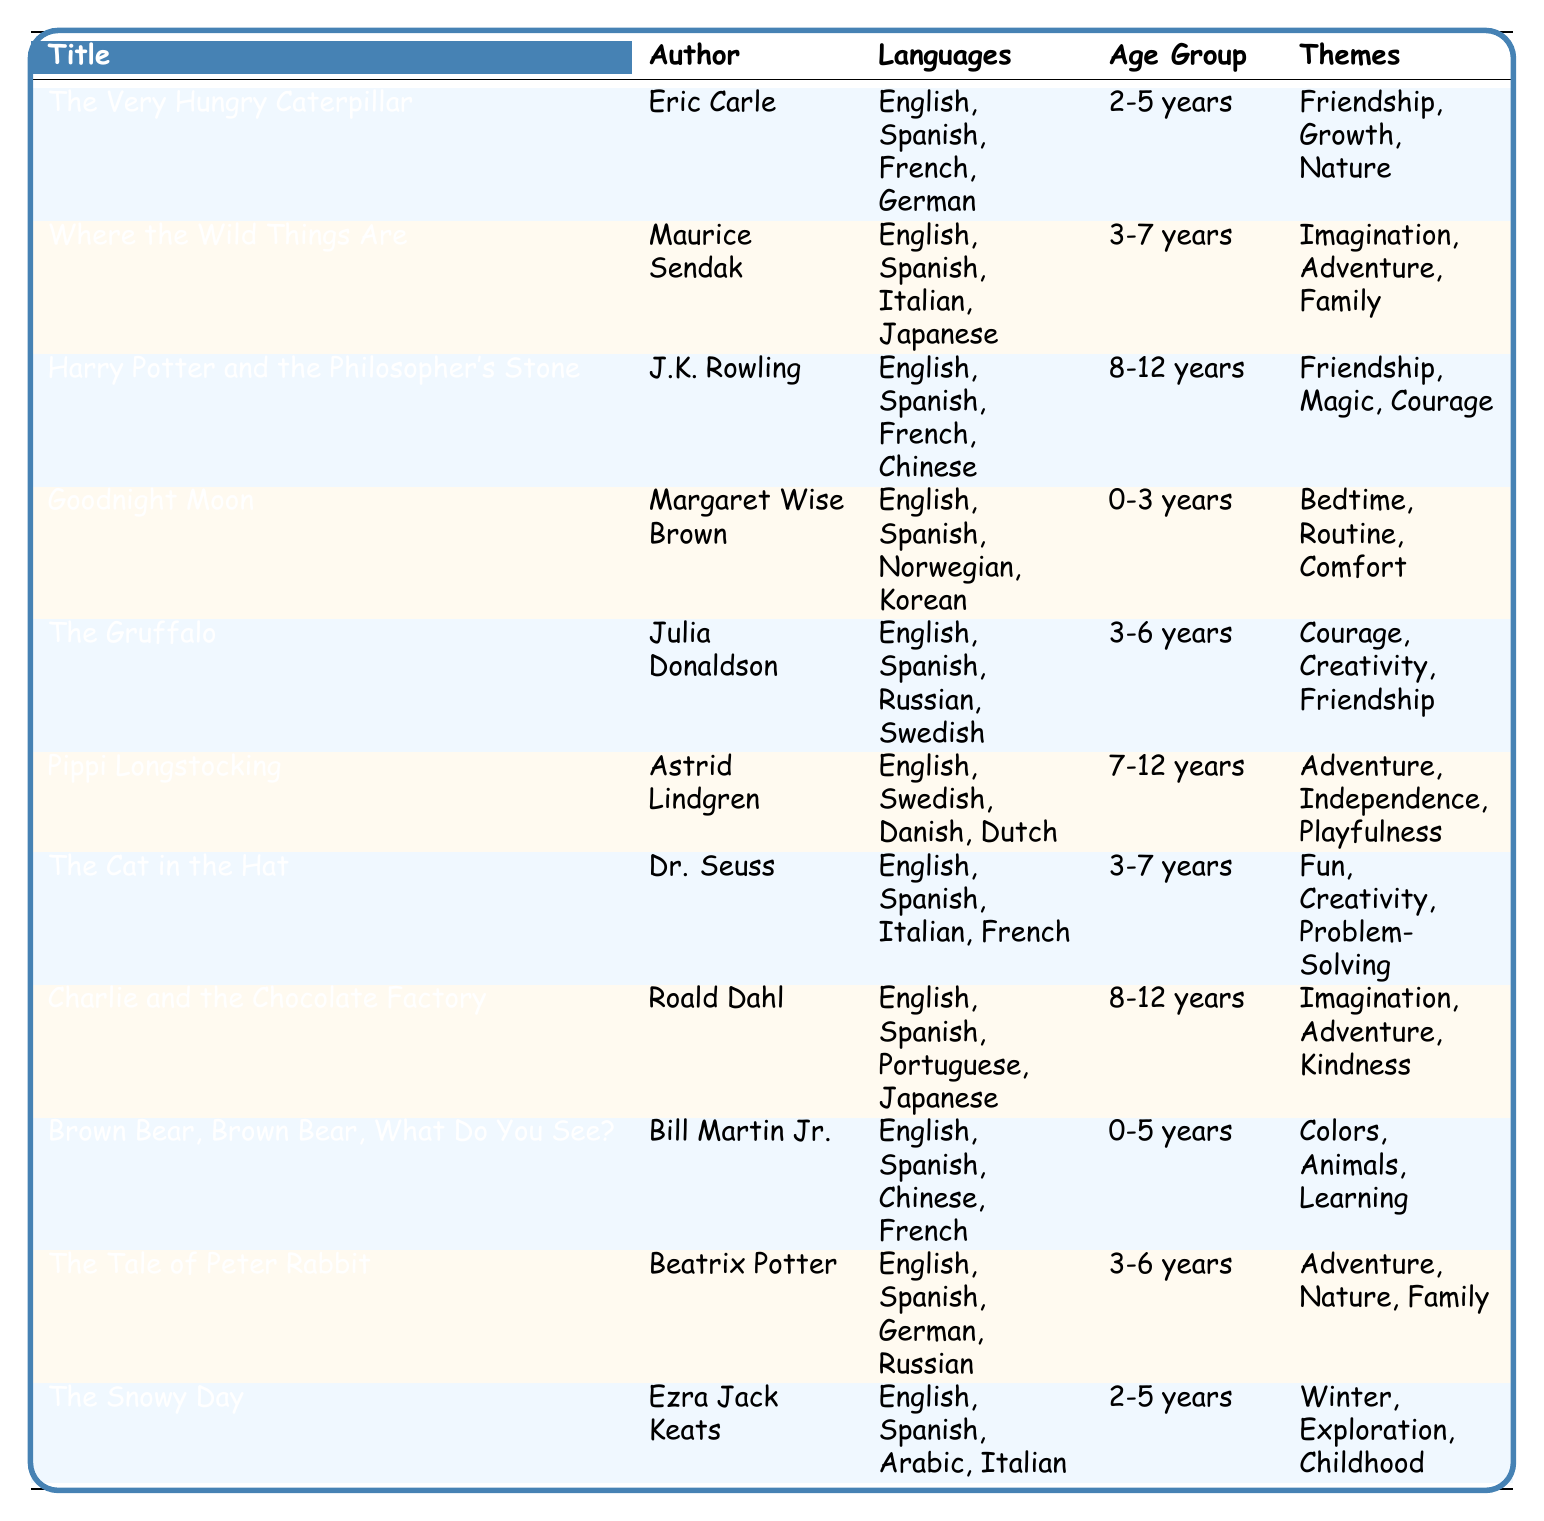What is the age group for "The Gruffalo"? The table shows that "The Gruffalo" falls under the age group of "3-6 years."
Answer: 3-6 years Which languages is "Goodnight Moon" available in? According to the table, "Goodnight Moon" is available in English, Spanish, Norwegian, and Korean.
Answer: English, Spanish, Norwegian, Korean Is "Harry Potter and the Philosopher's Stone" available in Chinese? The table indicates that "Harry Potter and the Philosopher's Stone" has Chinese listed among its available languages, confirming that it is indeed available in Chinese.
Answer: Yes How many books are available in Spanish? By reviewing the table, I see that the books available in Spanish are: "The Very Hungry Caterpillar," "Where the Wild Things Are," "Harry Potter and the Philosopher's Stone," "Goodnight Moon," "The Gruffalo," "The Cat in the Hat," "Brown Bear, Brown Bear, What Do You See?" and "The Tale of Peter Rabbit," totaling 8 books.
Answer: 8 What themes are associated with "The Snowy Day"? The table shows that the themes associated with "The Snowy Day" are Winter, Exploration, and Childhood.
Answer: Winter, Exploration, Childhood Which book has the theme of "Imagination" and is aimed at children aged 8-12 years? In the table, "Harry Potter and the Philosopher's Stone" and "Charlie and the Chocolate Factory" both have the theme of "Imagination" and are aimed at the age group 8-12 years.
Answer: Harry Potter and the Philosopher's Stone; Charlie and the Chocolate Factory How many unique themes are associated with books for the age group 2-5 years? The books for the age group 2-5 years are "The Very Hungry Caterpillar," "The Snowy Day," and "Brown Bear, Brown Bear, What Do You See?" The unique themes are: Friendship, Growth, Nature, Winter, Exploration, Childhood, Colors, Animals, and Learning. This results in a total of 7 unique themes.
Answer: 7 Are there any books available in both Italian and Spanish? The table shows that "Where the Wild Things Are" and "The Cat in the Hat" are available in Spanish and "Where the Wild Things Are" is also available in Italian. Therefore, there are books that satisfy this criterion.
Answer: Yes What is the average age group range for the books listed? Analyzing the age groups: 0-3 years, 2-5 years, 3-6 years, 3-7 years, 7-12 years, and 8-12 years, I find the ranges: 0-3 years (1 book), 2-5 years (2 books), 3-6 years (3 books), 3-7 years (2 books), 7-12 years (2 books), and 8-12 years (2 books). Calculating a weighted average based on the number of books in each group will give us a close approximation of the average age group range. The average is around 4-5 years old.
Answer: 4-5 years old 